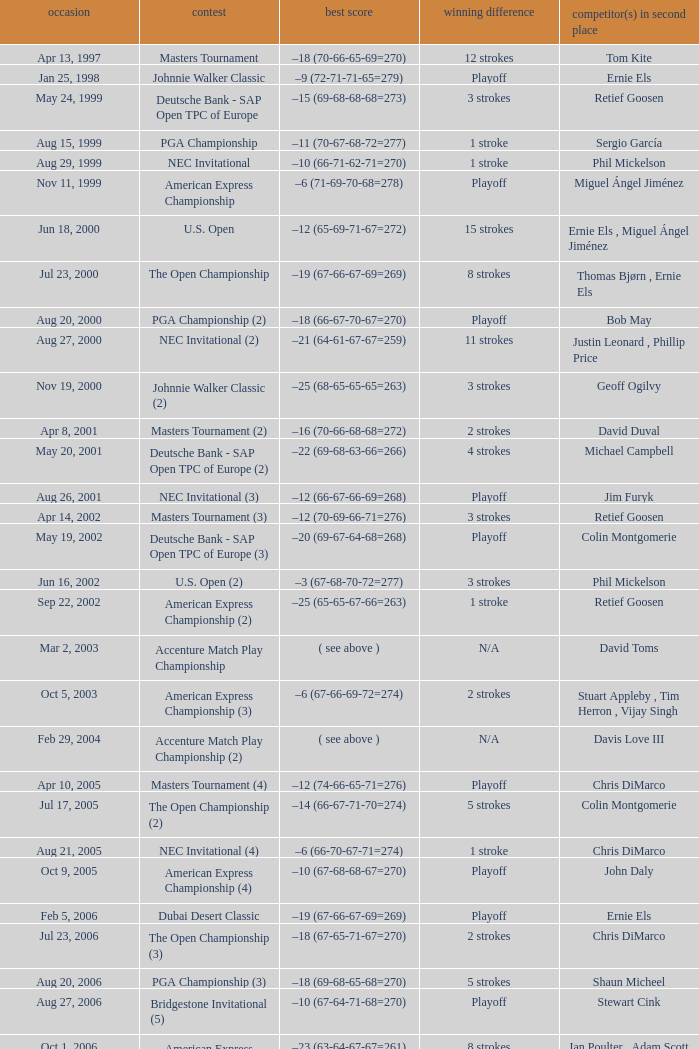Which Tournament has a Margin of victory of 7 strokes Bridgestone Invitational (8). Could you parse the entire table? {'header': ['occasion', 'contest', 'best score', 'winning difference', 'competitor(s) in second place'], 'rows': [['Apr 13, 1997', 'Masters Tournament', '–18 (70-66-65-69=270)', '12 strokes', 'Tom Kite'], ['Jan 25, 1998', 'Johnnie Walker Classic', '–9 (72-71-71-65=279)', 'Playoff', 'Ernie Els'], ['May 24, 1999', 'Deutsche Bank - SAP Open TPC of Europe', '–15 (69-68-68-68=273)', '3 strokes', 'Retief Goosen'], ['Aug 15, 1999', 'PGA Championship', '–11 (70-67-68-72=277)', '1 stroke', 'Sergio García'], ['Aug 29, 1999', 'NEC Invitational', '–10 (66-71-62-71=270)', '1 stroke', 'Phil Mickelson'], ['Nov 11, 1999', 'American Express Championship', '–6 (71-69-70-68=278)', 'Playoff', 'Miguel Ángel Jiménez'], ['Jun 18, 2000', 'U.S. Open', '–12 (65-69-71-67=272)', '15 strokes', 'Ernie Els , Miguel Ángel Jiménez'], ['Jul 23, 2000', 'The Open Championship', '–19 (67-66-67-69=269)', '8 strokes', 'Thomas Bjørn , Ernie Els'], ['Aug 20, 2000', 'PGA Championship (2)', '–18 (66-67-70-67=270)', 'Playoff', 'Bob May'], ['Aug 27, 2000', 'NEC Invitational (2)', '–21 (64-61-67-67=259)', '11 strokes', 'Justin Leonard , Phillip Price'], ['Nov 19, 2000', 'Johnnie Walker Classic (2)', '–25 (68-65-65-65=263)', '3 strokes', 'Geoff Ogilvy'], ['Apr 8, 2001', 'Masters Tournament (2)', '–16 (70-66-68-68=272)', '2 strokes', 'David Duval'], ['May 20, 2001', 'Deutsche Bank - SAP Open TPC of Europe (2)', '–22 (69-68-63-66=266)', '4 strokes', 'Michael Campbell'], ['Aug 26, 2001', 'NEC Invitational (3)', '–12 (66-67-66-69=268)', 'Playoff', 'Jim Furyk'], ['Apr 14, 2002', 'Masters Tournament (3)', '–12 (70-69-66-71=276)', '3 strokes', 'Retief Goosen'], ['May 19, 2002', 'Deutsche Bank - SAP Open TPC of Europe (3)', '–20 (69-67-64-68=268)', 'Playoff', 'Colin Montgomerie'], ['Jun 16, 2002', 'U.S. Open (2)', '–3 (67-68-70-72=277)', '3 strokes', 'Phil Mickelson'], ['Sep 22, 2002', 'American Express Championship (2)', '–25 (65-65-67-66=263)', '1 stroke', 'Retief Goosen'], ['Mar 2, 2003', 'Accenture Match Play Championship', '( see above )', 'N/A', 'David Toms'], ['Oct 5, 2003', 'American Express Championship (3)', '–6 (67-66-69-72=274)', '2 strokes', 'Stuart Appleby , Tim Herron , Vijay Singh'], ['Feb 29, 2004', 'Accenture Match Play Championship (2)', '( see above )', 'N/A', 'Davis Love III'], ['Apr 10, 2005', 'Masters Tournament (4)', '–12 (74-66-65-71=276)', 'Playoff', 'Chris DiMarco'], ['Jul 17, 2005', 'The Open Championship (2)', '–14 (66-67-71-70=274)', '5 strokes', 'Colin Montgomerie'], ['Aug 21, 2005', 'NEC Invitational (4)', '–6 (66-70-67-71=274)', '1 stroke', 'Chris DiMarco'], ['Oct 9, 2005', 'American Express Championship (4)', '–10 (67-68-68-67=270)', 'Playoff', 'John Daly'], ['Feb 5, 2006', 'Dubai Desert Classic', '–19 (67-66-67-69=269)', 'Playoff', 'Ernie Els'], ['Jul 23, 2006', 'The Open Championship (3)', '–18 (67-65-71-67=270)', '2 strokes', 'Chris DiMarco'], ['Aug 20, 2006', 'PGA Championship (3)', '–18 (69-68-65-68=270)', '5 strokes', 'Shaun Micheel'], ['Aug 27, 2006', 'Bridgestone Invitational (5)', '–10 (67-64-71-68=270)', 'Playoff', 'Stewart Cink'], ['Oct 1, 2006', 'American Express Championship (5)', '–23 (63-64-67-67=261)', '8 strokes', 'Ian Poulter , Adam Scott'], ['Mar 25, 2007', 'CA Championship (6)', '–10 (71-66-68-73=278)', '2 strokes', 'Brett Wetterich'], ['Aug 5, 2007', 'Bridgestone Invitational (6)', '−8 (68-70-69-65=272)', '8 strokes', 'Justin Rose , Rory Sabbatini'], ['Aug 12, 2007', 'PGA Championship (4)', '–8 (71-63-69-69=272)', '2 strokes', 'Woody Austin'], ['Feb 3, 2008', 'Dubai Desert Classic (2)', '–14 (65-71-73-65=274)', '1 stroke', 'Martin Kaymer'], ['Feb 24, 2008', 'Accenture Match Play Championship (3)', '( see above )', 'N/A', 'Stewart Cink'], ['Jun 16, 2008', 'U.S. Open (3)', '–1 (72-68-70-73=283)', 'Playoff', 'Rocco Mediate'], ['Aug 9, 2009', 'Bridgestone Invitational (7)', '−12 (68-70-65-65=268)', '4 strokes', 'Robert Allenby , Pádraig Harrington'], ['Nov 15, 2009', 'JBWere Masters', '–14 (66-68-72-68=274)', '2 strokes', 'Greg Chalmers'], ['Mar 10, 2013', 'Cadillac Championship (7)', '–19 (66-65-67-71=269)', '2 strokes', 'Steve Stricker'], ['Aug 4, 2013', 'Bridgestone Invitational (8)', '−15 (66-61-68-70=265)', '7 strokes', 'Keegan Bradley , Henrik Stenson']]} 